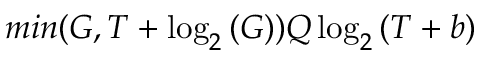<formula> <loc_0><loc_0><loc_500><loc_500>\min ( G , T + \log _ { 2 } { ( G ) } ) Q \log _ { 2 } { ( T + b ) }</formula> 